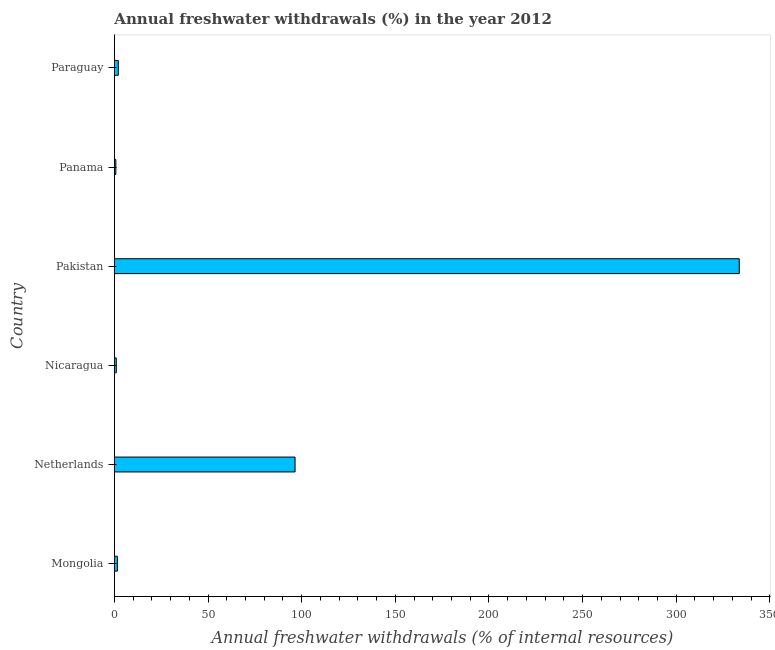Does the graph contain grids?
Provide a succinct answer. No. What is the title of the graph?
Provide a succinct answer. Annual freshwater withdrawals (%) in the year 2012. What is the label or title of the X-axis?
Make the answer very short. Annual freshwater withdrawals (% of internal resources). What is the annual freshwater withdrawals in Nicaragua?
Provide a succinct answer. 0.99. Across all countries, what is the maximum annual freshwater withdrawals?
Make the answer very short. 333.64. Across all countries, what is the minimum annual freshwater withdrawals?
Make the answer very short. 0.76. In which country was the annual freshwater withdrawals minimum?
Your answer should be compact. Panama. What is the sum of the annual freshwater withdrawals?
Give a very brief answer. 435.48. What is the difference between the annual freshwater withdrawals in Mongolia and Nicaragua?
Your answer should be very brief. 0.59. What is the average annual freshwater withdrawals per country?
Keep it short and to the point. 72.58. What is the median annual freshwater withdrawals?
Offer a very short reply. 1.82. What is the ratio of the annual freshwater withdrawals in Pakistan to that in Paraguay?
Keep it short and to the point. 161.77. Is the difference between the annual freshwater withdrawals in Mongolia and Pakistan greater than the difference between any two countries?
Make the answer very short. No. What is the difference between the highest and the second highest annual freshwater withdrawals?
Provide a succinct answer. 237.18. Is the sum of the annual freshwater withdrawals in Netherlands and Pakistan greater than the maximum annual freshwater withdrawals across all countries?
Make the answer very short. Yes. What is the difference between the highest and the lowest annual freshwater withdrawals?
Offer a terse response. 332.88. How many bars are there?
Your answer should be compact. 6. Are all the bars in the graph horizontal?
Make the answer very short. Yes. What is the difference between two consecutive major ticks on the X-axis?
Your response must be concise. 50. Are the values on the major ticks of X-axis written in scientific E-notation?
Provide a short and direct response. No. What is the Annual freshwater withdrawals (% of internal resources) in Mongolia?
Make the answer very short. 1.58. What is the Annual freshwater withdrawals (% of internal resources) of Netherlands?
Your answer should be compact. 96.45. What is the Annual freshwater withdrawals (% of internal resources) in Nicaragua?
Your answer should be very brief. 0.99. What is the Annual freshwater withdrawals (% of internal resources) in Pakistan?
Give a very brief answer. 333.64. What is the Annual freshwater withdrawals (% of internal resources) of Panama?
Offer a terse response. 0.76. What is the Annual freshwater withdrawals (% of internal resources) in Paraguay?
Your answer should be very brief. 2.06. What is the difference between the Annual freshwater withdrawals (% of internal resources) in Mongolia and Netherlands?
Provide a succinct answer. -94.87. What is the difference between the Annual freshwater withdrawals (% of internal resources) in Mongolia and Nicaragua?
Give a very brief answer. 0.59. What is the difference between the Annual freshwater withdrawals (% of internal resources) in Mongolia and Pakistan?
Keep it short and to the point. -332.05. What is the difference between the Annual freshwater withdrawals (% of internal resources) in Mongolia and Panama?
Ensure brevity in your answer.  0.82. What is the difference between the Annual freshwater withdrawals (% of internal resources) in Mongolia and Paraguay?
Offer a terse response. -0.48. What is the difference between the Annual freshwater withdrawals (% of internal resources) in Netherlands and Nicaragua?
Provide a short and direct response. 95.47. What is the difference between the Annual freshwater withdrawals (% of internal resources) in Netherlands and Pakistan?
Ensure brevity in your answer.  -237.18. What is the difference between the Annual freshwater withdrawals (% of internal resources) in Netherlands and Panama?
Your response must be concise. 95.7. What is the difference between the Annual freshwater withdrawals (% of internal resources) in Netherlands and Paraguay?
Your answer should be compact. 94.39. What is the difference between the Annual freshwater withdrawals (% of internal resources) in Nicaragua and Pakistan?
Keep it short and to the point. -332.65. What is the difference between the Annual freshwater withdrawals (% of internal resources) in Nicaragua and Panama?
Provide a succinct answer. 0.23. What is the difference between the Annual freshwater withdrawals (% of internal resources) in Nicaragua and Paraguay?
Your answer should be very brief. -1.07. What is the difference between the Annual freshwater withdrawals (% of internal resources) in Pakistan and Panama?
Give a very brief answer. 332.88. What is the difference between the Annual freshwater withdrawals (% of internal resources) in Pakistan and Paraguay?
Offer a terse response. 331.57. What is the difference between the Annual freshwater withdrawals (% of internal resources) in Panama and Paraguay?
Your answer should be compact. -1.3. What is the ratio of the Annual freshwater withdrawals (% of internal resources) in Mongolia to that in Netherlands?
Offer a very short reply. 0.02. What is the ratio of the Annual freshwater withdrawals (% of internal resources) in Mongolia to that in Nicaragua?
Your answer should be compact. 1.6. What is the ratio of the Annual freshwater withdrawals (% of internal resources) in Mongolia to that in Pakistan?
Provide a short and direct response. 0.01. What is the ratio of the Annual freshwater withdrawals (% of internal resources) in Mongolia to that in Panama?
Make the answer very short. 2.09. What is the ratio of the Annual freshwater withdrawals (% of internal resources) in Mongolia to that in Paraguay?
Provide a succinct answer. 0.77. What is the ratio of the Annual freshwater withdrawals (% of internal resources) in Netherlands to that in Nicaragua?
Your answer should be compact. 97.52. What is the ratio of the Annual freshwater withdrawals (% of internal resources) in Netherlands to that in Pakistan?
Your answer should be compact. 0.29. What is the ratio of the Annual freshwater withdrawals (% of internal resources) in Netherlands to that in Panama?
Offer a terse response. 127.06. What is the ratio of the Annual freshwater withdrawals (% of internal resources) in Netherlands to that in Paraguay?
Offer a terse response. 46.77. What is the ratio of the Annual freshwater withdrawals (% of internal resources) in Nicaragua to that in Pakistan?
Offer a very short reply. 0. What is the ratio of the Annual freshwater withdrawals (% of internal resources) in Nicaragua to that in Panama?
Provide a succinct answer. 1.3. What is the ratio of the Annual freshwater withdrawals (% of internal resources) in Nicaragua to that in Paraguay?
Provide a succinct answer. 0.48. What is the ratio of the Annual freshwater withdrawals (% of internal resources) in Pakistan to that in Panama?
Offer a very short reply. 439.49. What is the ratio of the Annual freshwater withdrawals (% of internal resources) in Pakistan to that in Paraguay?
Provide a succinct answer. 161.77. What is the ratio of the Annual freshwater withdrawals (% of internal resources) in Panama to that in Paraguay?
Your response must be concise. 0.37. 